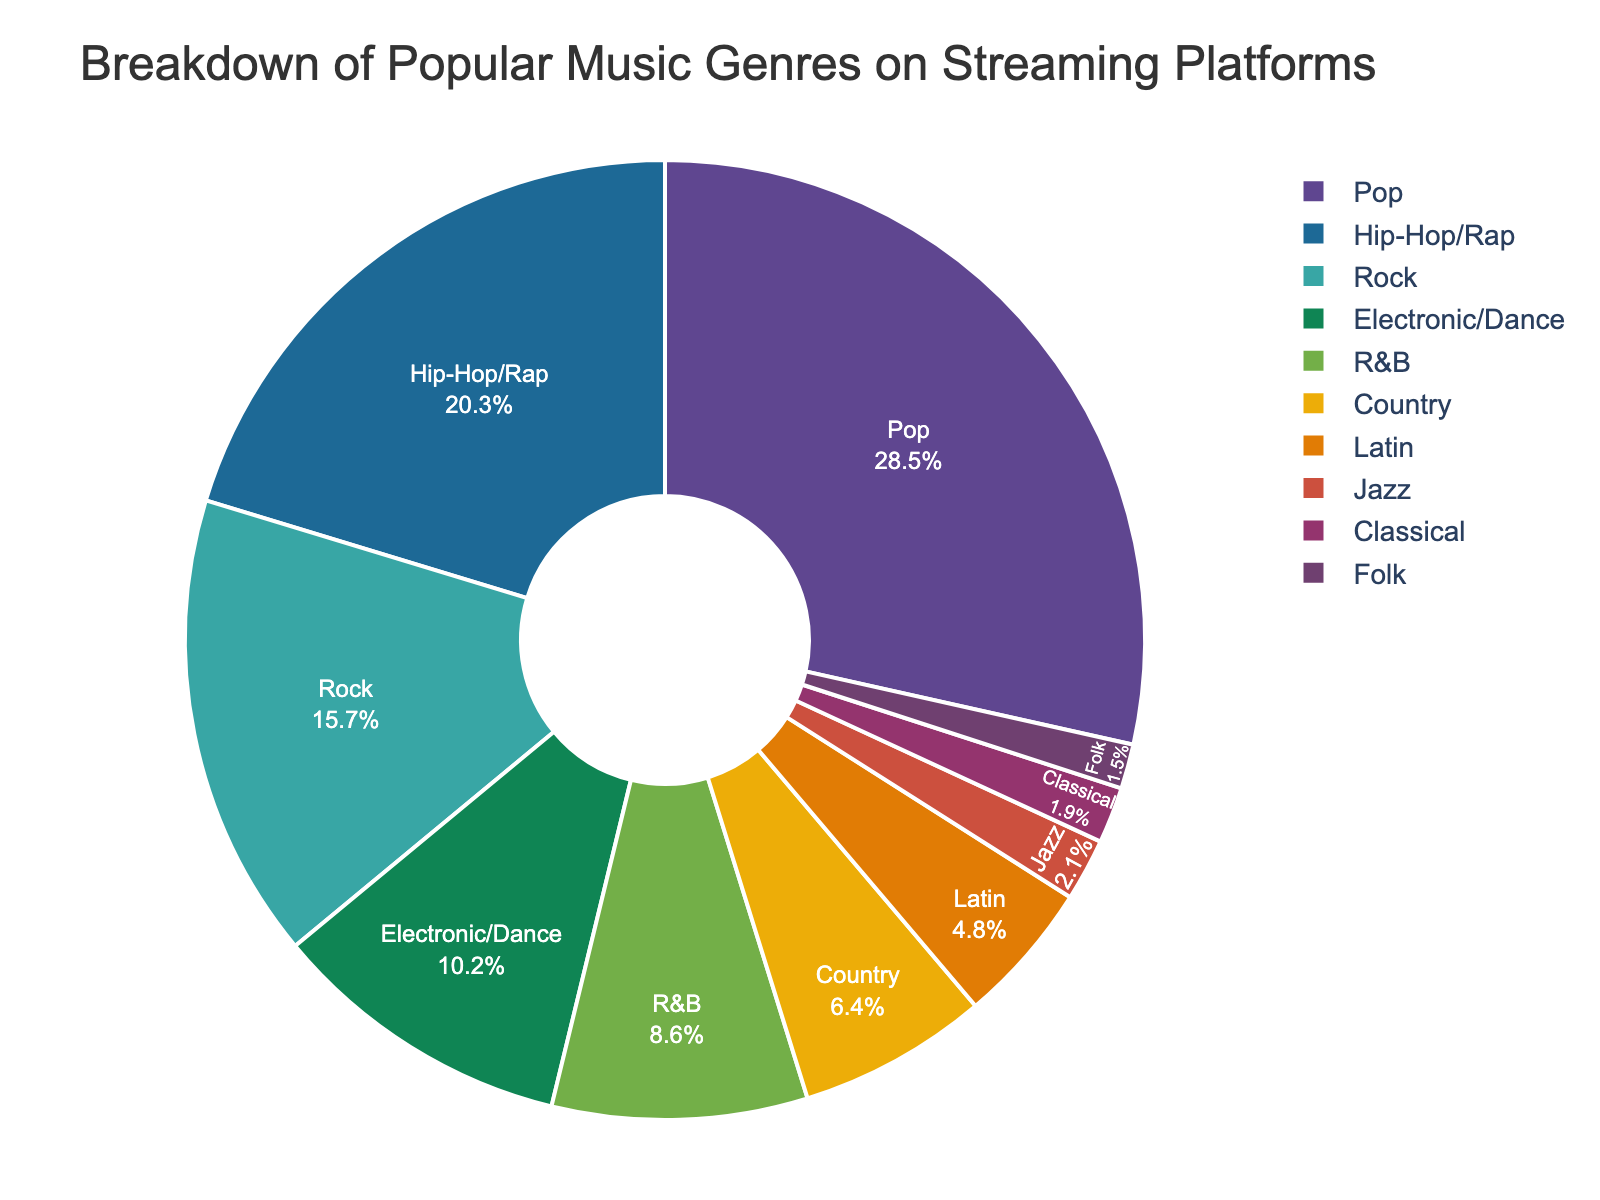What's the total percentage of Rock and Country genres combined? To find the total percentage, add the percentages of Rock and Country from the figure. Rock has 15.7% and Country has 6.4%. Adding them together: 15.7 + 6.4 = 22.1%.
Answer: 22.1% Which genre has a higher percentage, Hip-Hop/Rap or R&B? Compare the percentages of Hip-Hop/Rap and R&B from the figure. Hip-Hop/Rap has 20.3% and R&B has 8.6%. 20.3% is greater than 8.6%.
Answer: Hip-Hop/Rap How much more popular is Pop compared to Folk according to the figure? Determine the difference between the percentages of Pop and Folk. Pop has 28.5% and Folk has 1.5%. Subtract 1.5 from 28.5: 28.5 - 1.5 = 27%.
Answer: 27% What's the combined percentage of genres that have less than 5% each? Identify genres with less than 5%: Classical (1.9%), Jazz (2.1%), Folk (1.5%), and Latin (4.8%). Sum these values: 1.9 + 2.1 + 1.5 + 4.8 = 10.3%.
Answer: 10.3% Are there more genres with above or below 10% share? How many genres fall into each category? Count the genres with above 10%: Pop, Hip-Hop/Rap, and Rock. That's 3 genres. Now count those below 10%: Electronic/Dance, R&B, Country, Latin, Jazz, Classical, and Folk. That's 7 genres. There are more genres below 10%.
Answer: More genres below 10%, with totals of 7 below and 3 above 10% Which genres make up less than 3% of the total? Identify genres with less than 3% according to the figure. These are Jazz (2.1%), Classical (1.9%), and Folk (1.5%).
Answer: Jazz, Classical, Folk Which genre occupies the largest segment in the pie chart? Observe the size of each segment in the pie chart. The genre with the largest segment is Pop, which has 28.5%.
Answer: Pop How much larger is the percentage of Electronic/Dance compared to Classical? Find the difference between the percentages of Electronic/Dance and Classical. Electronic/Dance has 10.2% and Classical has 1.9%. Subtract 1.9 from 10.2: 10.2 - 1.9 = 8.3%.
Answer: 8.3% What's the average percentage of the top three most popular genres? Identify the top three genres by percentage: Pop (28.5%), Hip-Hop/Rap (20.3%), and Rock (15.7%). Calculate the average: (28.5 + 20.3 + 15.7) / 3 = 64.5 / 3 = 21.5%.
Answer: 21.5% 